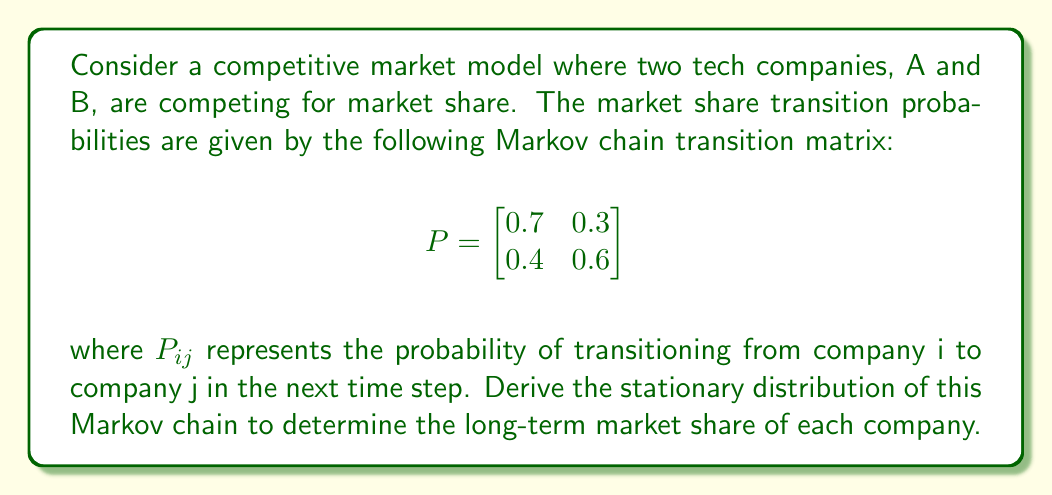Teach me how to tackle this problem. To derive the stationary distribution of this Markov chain, we need to follow these steps:

1) The stationary distribution $\pi = [\pi_A, \pi_B]$ satisfies the equation $\pi P = \pi$, where $P$ is the transition matrix.

2) This gives us the system of equations:
   $$\pi_A = 0.7\pi_A + 0.4\pi_B$$
   $$\pi_B = 0.3\pi_A + 0.6\pi_B$$

3) We also know that $\pi_A + \pi_B = 1$ (the probabilities sum to 1).

4) From the first equation:
   $$\pi_A = 0.7\pi_A + 0.4\pi_B$$
   $$0.3\pi_A = 0.4\pi_B$$
   $$\pi_A = \frac{4}{3}\pi_B$$

5) Substituting this into $\pi_A + \pi_B = 1$:
   $$\frac{4}{3}\pi_B + \pi_B = 1$$
   $$\frac{7}{3}\pi_B = 1$$
   $$\pi_B = \frac{3}{7}$$

6) And consequently:
   $$\pi_A = 1 - \pi_B = 1 - \frac{3}{7} = \frac{4}{7}$$

7) We can verify this solution satisfies the original equations:
   $$\frac{4}{7} = 0.7(\frac{4}{7}) + 0.4(\frac{3}{7}) = \frac{28}{70} + \frac{12}{70} = \frac{40}{70} = \frac{4}{7}$$
   $$\frac{3}{7} = 0.3(\frac{4}{7}) + 0.6(\frac{3}{7}) = \frac{12}{70} + \frac{18}{70} = \frac{30}{70} = \frac{3}{7}$$

Therefore, the stationary distribution is $\pi = [\frac{4}{7}, \frac{3}{7}]$.
Answer: $\pi = [\frac{4}{7}, \frac{3}{7}]$ 